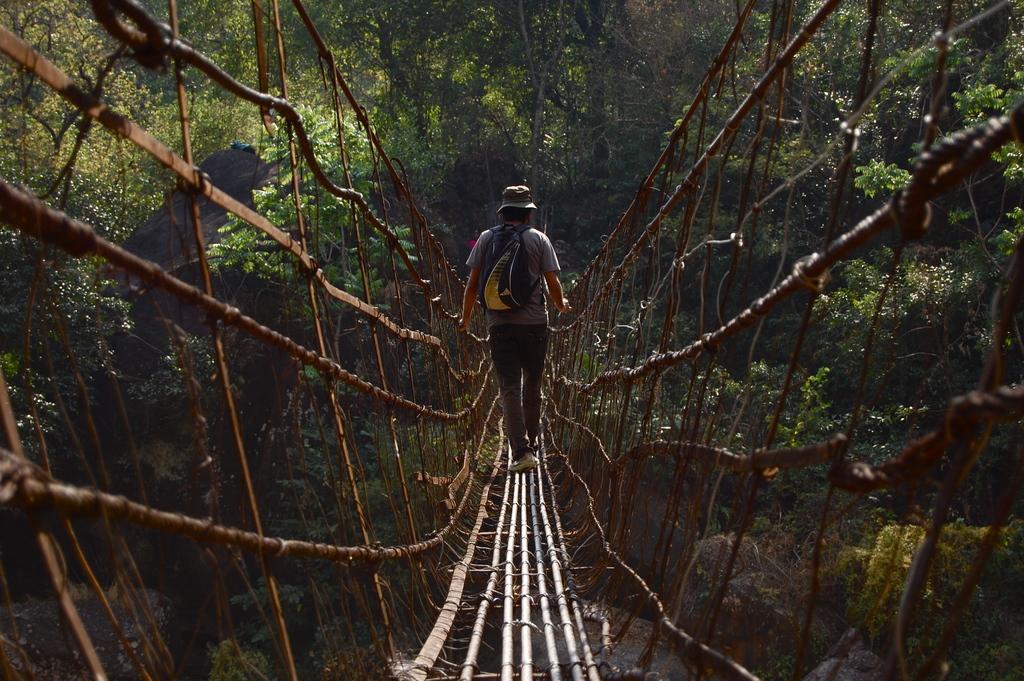Describe this image in one or two sentences. The man in grey T-shirt is walking on the living root bridge or a rope bridge. In the background, there are trees. 